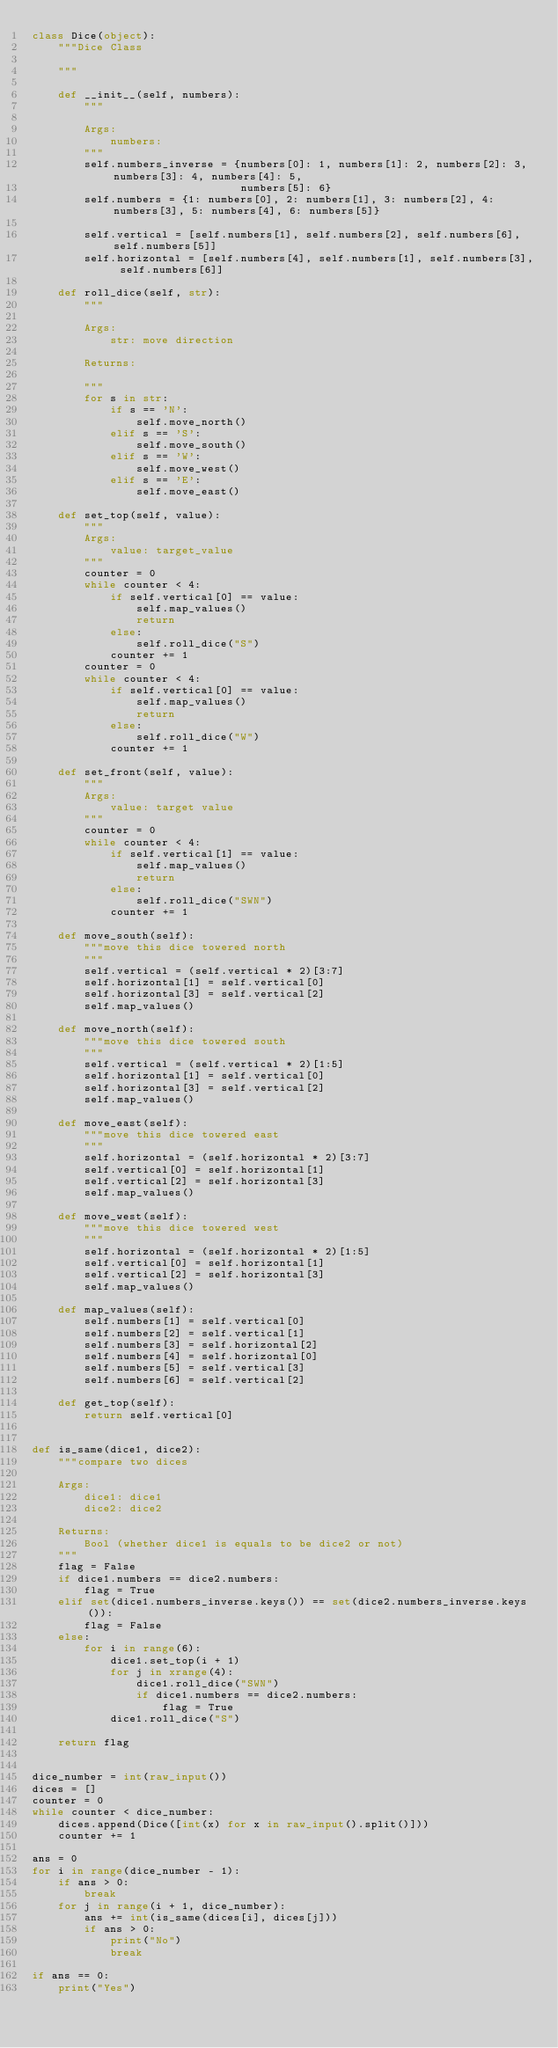Convert code to text. <code><loc_0><loc_0><loc_500><loc_500><_Python_>class Dice(object):
    """Dice Class

    """

    def __init__(self, numbers):
        """

        Args:
            numbers:
        """
        self.numbers_inverse = {numbers[0]: 1, numbers[1]: 2, numbers[2]: 3, numbers[3]: 4, numbers[4]: 5,
                                numbers[5]: 6}
        self.numbers = {1: numbers[0], 2: numbers[1], 3: numbers[2], 4: numbers[3], 5: numbers[4], 6: numbers[5]}

        self.vertical = [self.numbers[1], self.numbers[2], self.numbers[6], self.numbers[5]]
        self.horizontal = [self.numbers[4], self.numbers[1], self.numbers[3], self.numbers[6]]

    def roll_dice(self, str):
        """

        Args:
            str: move direction

        Returns:

        """
        for s in str:
            if s == 'N':
                self.move_north()
            elif s == 'S':
                self.move_south()
            elif s == 'W':
                self.move_west()
            elif s == 'E':
                self.move_east()

    def set_top(self, value):
        """
        Args:
            value: target_value
        """
        counter = 0
        while counter < 4:
            if self.vertical[0] == value:
                self.map_values()
                return
            else:
                self.roll_dice("S")
            counter += 1
        counter = 0
        while counter < 4:
            if self.vertical[0] == value:
                self.map_values()
                return
            else:
                self.roll_dice("W")
            counter += 1

    def set_front(self, value):
        """
        Args:
            value: target value
        """
        counter = 0
        while counter < 4:
            if self.vertical[1] == value:
                self.map_values()
                return
            else:
                self.roll_dice("SWN")
            counter += 1

    def move_south(self):
        """move this dice towered north
        """
        self.vertical = (self.vertical * 2)[3:7]
        self.horizontal[1] = self.vertical[0]
        self.horizontal[3] = self.vertical[2]
        self.map_values()

    def move_north(self):
        """move this dice towered south
        """
        self.vertical = (self.vertical * 2)[1:5]
        self.horizontal[1] = self.vertical[0]
        self.horizontal[3] = self.vertical[2]
        self.map_values()

    def move_east(self):
        """move this dice towered east
        """
        self.horizontal = (self.horizontal * 2)[3:7]
        self.vertical[0] = self.horizontal[1]
        self.vertical[2] = self.horizontal[3]
        self.map_values()

    def move_west(self):
        """move this dice towered west
        """
        self.horizontal = (self.horizontal * 2)[1:5]
        self.vertical[0] = self.horizontal[1]
        self.vertical[2] = self.horizontal[3]
        self.map_values()

    def map_values(self):
        self.numbers[1] = self.vertical[0]
        self.numbers[2] = self.vertical[1]
        self.numbers[3] = self.horizontal[2]
        self.numbers[4] = self.horizontal[0]
        self.numbers[5] = self.vertical[3]
        self.numbers[6] = self.vertical[2]

    def get_top(self):
        return self.vertical[0]


def is_same(dice1, dice2):
    """compare two dices

    Args:
        dice1: dice1
        dice2: dice2

    Returns:
        Bool (whether dice1 is equals to be dice2 or not)
    """
    flag = False
    if dice1.numbers == dice2.numbers:
        flag = True
    elif set(dice1.numbers_inverse.keys()) == set(dice2.numbers_inverse.keys()):
        flag = False
    else:
        for i in range(6):
            dice1.set_top(i + 1)
            for j in xrange(4):
                dice1.roll_dice("SWN")
                if dice1.numbers == dice2.numbers:
                    flag = True
            dice1.roll_dice("S")

    return flag


dice_number = int(raw_input())
dices = []
counter = 0
while counter < dice_number:
    dices.append(Dice([int(x) for x in raw_input().split()]))
    counter += 1

ans = 0
for i in range(dice_number - 1):
    if ans > 0:
        break
    for j in range(i + 1, dice_number):
        ans += int(is_same(dices[i], dices[j]))
        if ans > 0:
            print("No")
            break

if ans == 0:
    print("Yes")</code> 